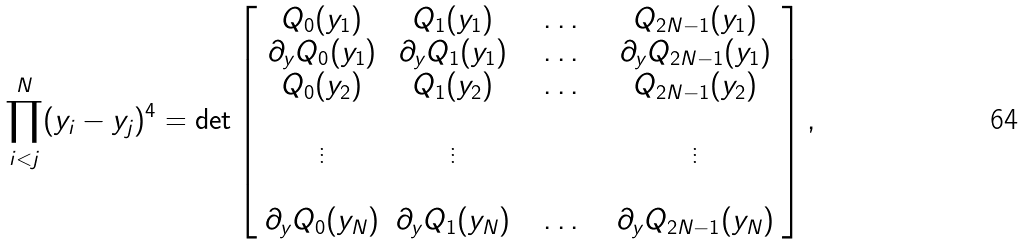Convert formula to latex. <formula><loc_0><loc_0><loc_500><loc_500>\prod _ { i < j } ^ { N } ( y _ { i } - y _ { j } ) ^ { 4 } = \det \left [ \begin{array} { c c c c c c } Q _ { 0 } ( y _ { 1 } ) & Q _ { 1 } ( y _ { 1 } ) & & \dots & & Q _ { 2 N - 1 } ( y _ { 1 } ) \\ \partial _ { y } Q _ { 0 } ( y _ { 1 } ) & \partial _ { y } Q _ { 1 } ( y _ { 1 } ) & & \dots & & \partial _ { y } Q _ { 2 N - 1 } ( y _ { 1 } ) \\ Q _ { 0 } ( y _ { 2 } ) & Q _ { 1 } ( y _ { 2 } ) & & \dots & & Q _ { 2 N - 1 } ( y _ { 2 } ) \\ & & & & & \\ \vdots & \vdots & & & & \vdots \\ & & & & & \\ \partial _ { y } Q _ { 0 } ( y _ { N } ) & \partial _ { y } Q _ { 1 } ( y _ { N } ) & & \dots & & \partial _ { y } Q _ { 2 N - 1 } ( y _ { N } ) \end{array} \right ] ,</formula> 